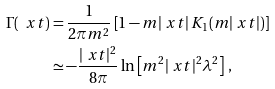<formula> <loc_0><loc_0><loc_500><loc_500>\Gamma ( \ x t ) & = \frac { 1 } { 2 \pi m ^ { 2 } } \left [ 1 - m | \ x t | \, K _ { 1 } ( m | \ x t | ) \right ] \\ & \simeq - \frac { | \ x t | ^ { 2 } } { 8 \pi } \ln \left [ m ^ { 2 } | \ x t | ^ { 2 } \lambda ^ { 2 } \right ] \, ,</formula> 